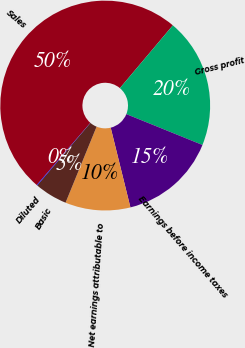Convert chart to OTSL. <chart><loc_0><loc_0><loc_500><loc_500><pie_chart><fcel>Sales<fcel>Gross profit<fcel>Earnings before income taxes<fcel>Net earnings attributable to<fcel>Basic<fcel>Diluted<nl><fcel>49.83%<fcel>19.98%<fcel>15.01%<fcel>10.03%<fcel>5.06%<fcel>0.09%<nl></chart> 